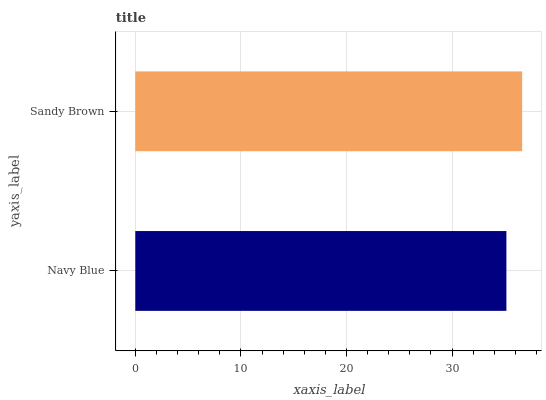Is Navy Blue the minimum?
Answer yes or no. Yes. Is Sandy Brown the maximum?
Answer yes or no. Yes. Is Sandy Brown the minimum?
Answer yes or no. No. Is Sandy Brown greater than Navy Blue?
Answer yes or no. Yes. Is Navy Blue less than Sandy Brown?
Answer yes or no. Yes. Is Navy Blue greater than Sandy Brown?
Answer yes or no. No. Is Sandy Brown less than Navy Blue?
Answer yes or no. No. Is Sandy Brown the high median?
Answer yes or no. Yes. Is Navy Blue the low median?
Answer yes or no. Yes. Is Navy Blue the high median?
Answer yes or no. No. Is Sandy Brown the low median?
Answer yes or no. No. 